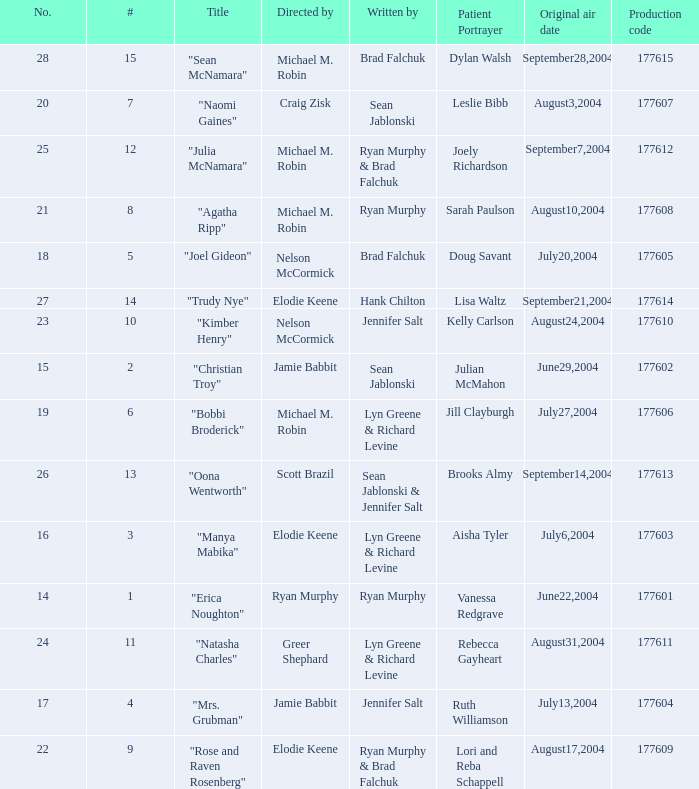What numbered episode is titled "naomi gaines"? 20.0. 